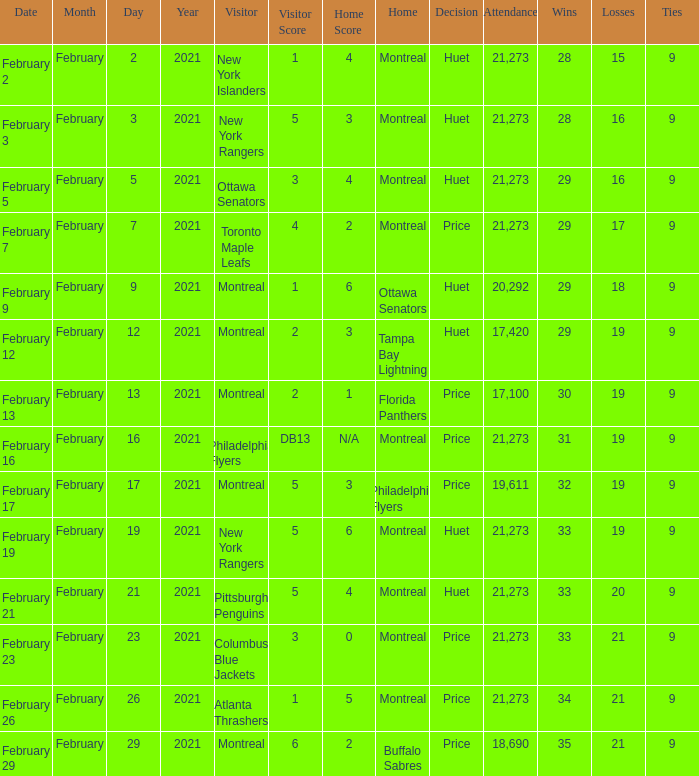Who was the visiting team at the game when the Canadiens had a record of 30–19–9? Montreal. 